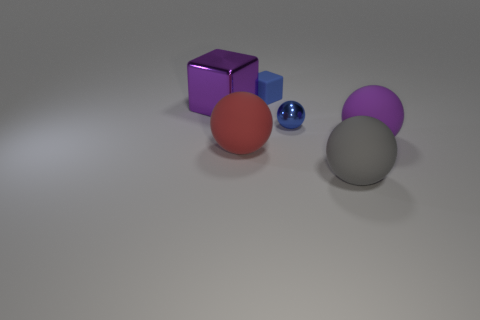Do the metallic block and the small shiny thing have the same color?
Provide a succinct answer. No. Is there a thing that has the same size as the blue block?
Offer a terse response. Yes. What is the size of the thing behind the big object that is behind the purple ball?
Give a very brief answer. Small. What number of shiny spheres are the same color as the small rubber block?
Offer a terse response. 1. What shape is the metallic thing that is left of the matte sphere to the left of the blue matte object?
Make the answer very short. Cube. What number of small gray cylinders are made of the same material as the big cube?
Your answer should be very brief. 0. What material is the red thing in front of the big metal thing?
Provide a short and direct response. Rubber. There is a rubber object that is in front of the rubber ball that is to the left of the cube behind the purple metal cube; what is its shape?
Provide a succinct answer. Sphere. There is a large rubber sphere left of the metallic sphere; does it have the same color as the thing that is to the right of the gray rubber ball?
Give a very brief answer. No. Is the number of tiny blue matte things behind the small matte block less than the number of large red objects that are on the left side of the big block?
Your answer should be very brief. No. 